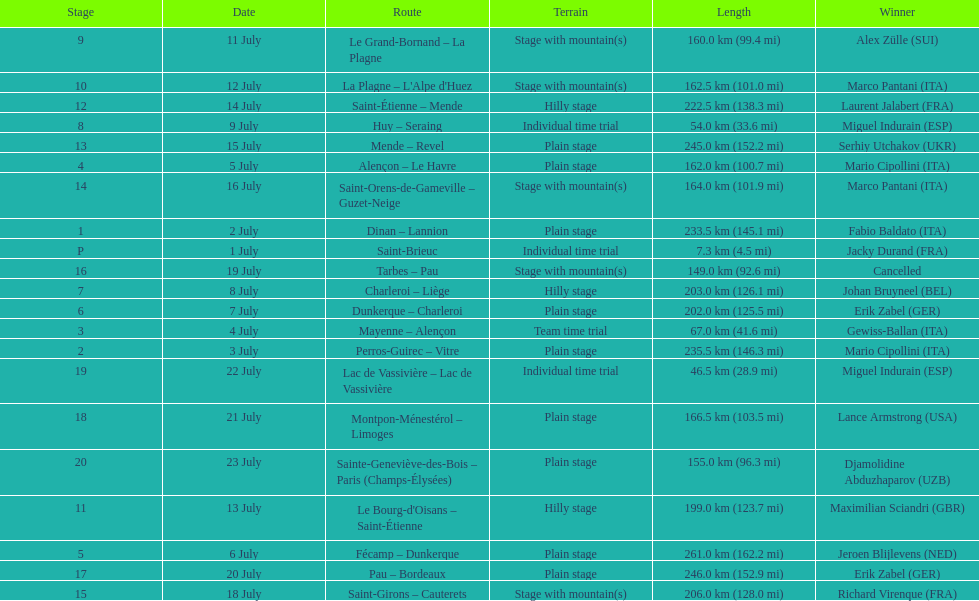How many consecutive km were raced on july 8th? 203.0 km (126.1 mi). 